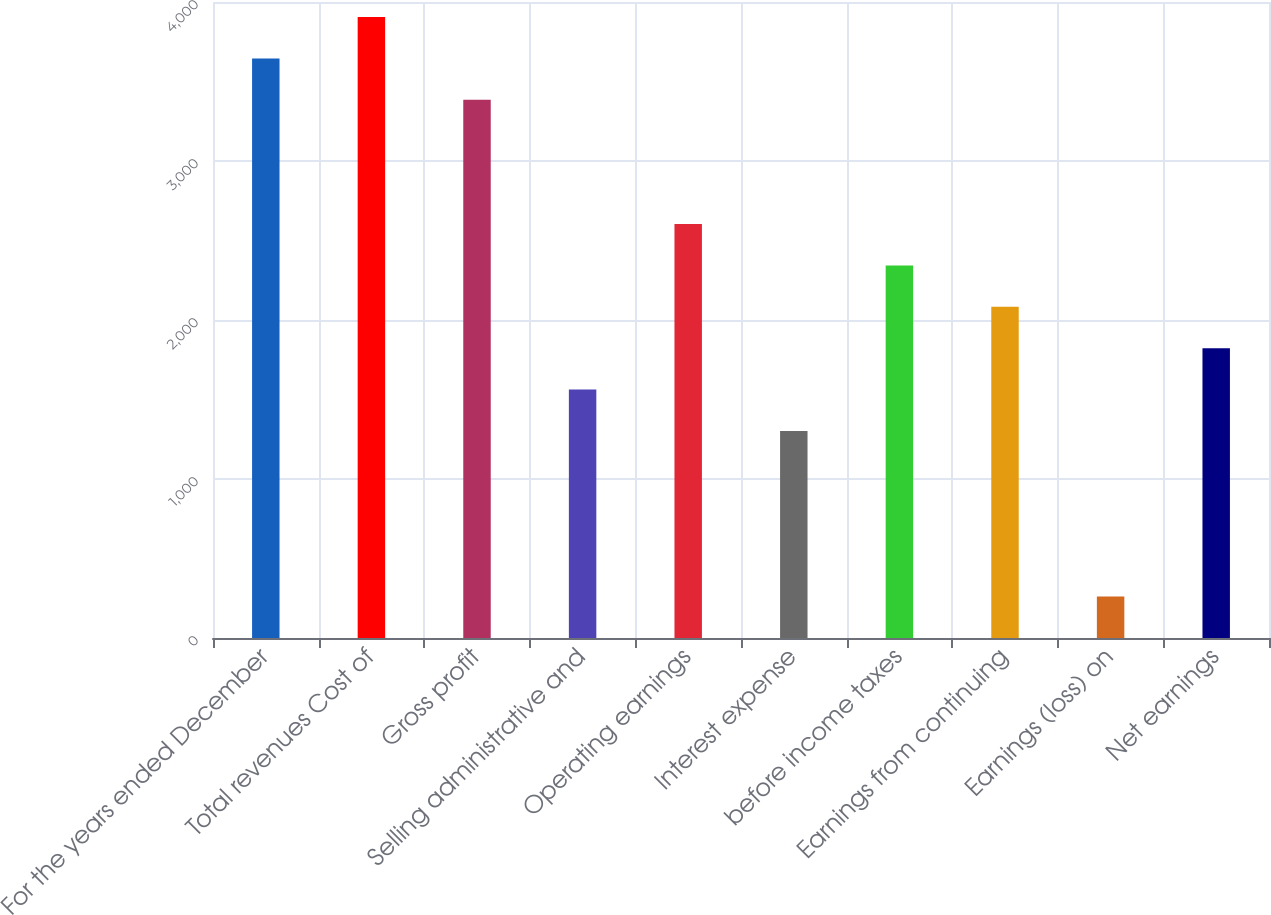Convert chart. <chart><loc_0><loc_0><loc_500><loc_500><bar_chart><fcel>For the years ended December<fcel>Total revenues Cost of<fcel>Gross profit<fcel>Selling administrative and<fcel>Operating earnings<fcel>Interest expense<fcel>before income taxes<fcel>Earnings from continuing<fcel>Earnings (loss) on<fcel>Net earnings<nl><fcel>3645.34<fcel>3905.72<fcel>3384.96<fcel>1562.3<fcel>2603.82<fcel>1301.92<fcel>2343.44<fcel>2083.06<fcel>260.4<fcel>1822.68<nl></chart> 